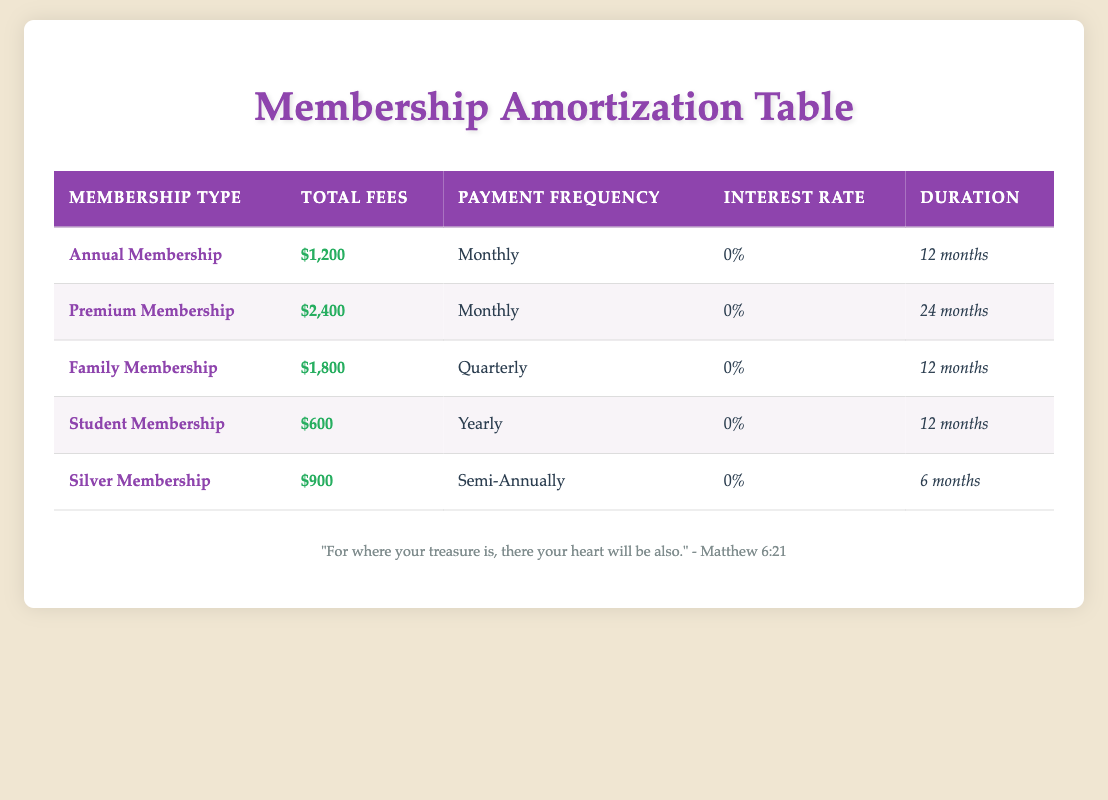What is the total fees for the Family Membership? The Family Membership is listed in the table with a total fee of $1,800.
Answer: 1,800 How many months is the duration of the Premium Membership? The duration for the Premium Membership is specified in the table as 24 months.
Answer: 24 months Is the interest rate for the Annual Membership greater than 0%? The interest rate for the Annual Membership is 0%, which means it is not greater than 0%.
Answer: No What is the total amount of fees for all membership types combined? To find the total fees, we sum the total fees for each membership type: 1200 + 2400 + 1800 + 600 + 900 = 7200.
Answer: 7,200 How many different payment frequencies are listed in the table? The payment frequencies listed are Monthly, Quarterly, Yearly, and Semi-Annually, which totals to four distinct payment frequencies.
Answer: 4 What is the average total fee of all the memberships? We must sum the total fees (1200 + 2400 + 1800 + 600 + 900 = 7200) and divide by the number of membership types (5). The average is 7200 / 5 = 1440.
Answer: 1,440 Is the Student Membership fee less than both the Silver Membership and the Family Membership fees? The Student Membership fee is $600, which is less than the Silver Membership fee of $900 and the Family Membership fee of $1,800. Therefore, the statement is true.
Answer: Yes What is the fee difference between the Premium Membership and the Annual Membership? The Premium Membership fees are $2,400 and the Annual Membership fees are $1,200. The difference is calculated by subtracting: 2400 - 1200 = 1200.
Answer: 1,200 How many memberships have a duration of less than one year? The memberships with durations of less than a year are the Silver Membership (6 months) and the Family Membership (12 months), making a total of one membership under 12 months.
Answer: 1 How many memberships have an equal duration of 12 months? According to the table, the memberships with a duration of 12 months are the Annual Membership, Family Membership, and Student Membership, giving us a total of 3 memberships.
Answer: 3 